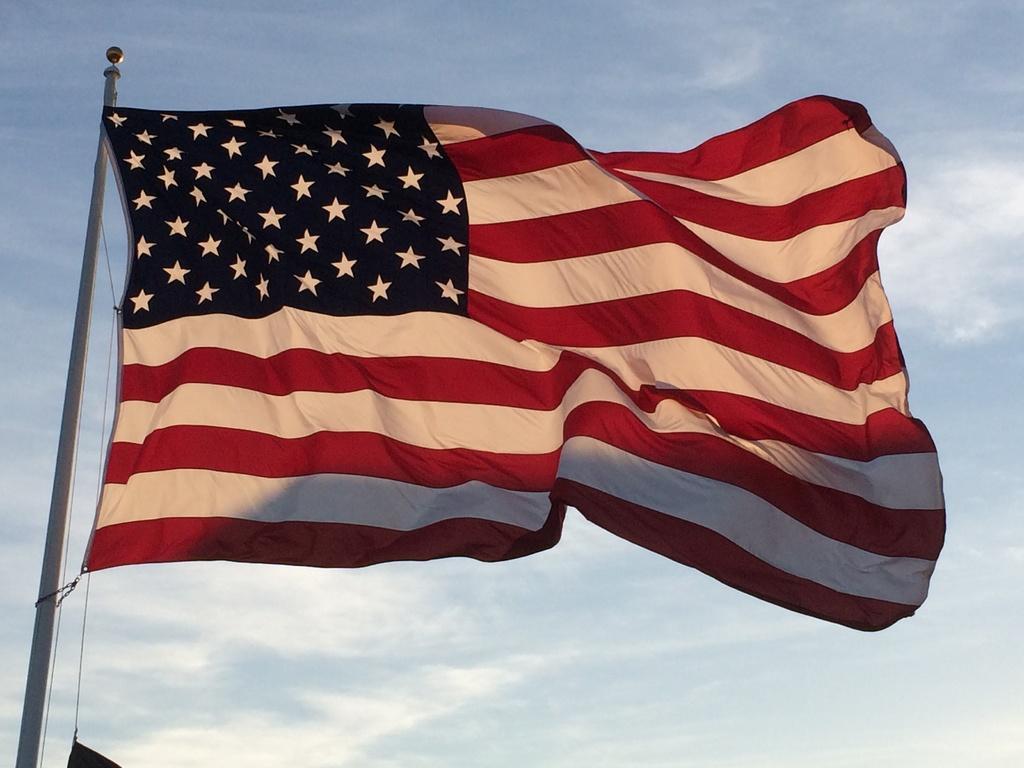Can you describe this image briefly? In this picture we can see the American flag here, on the left side there is a flag post, in the background there is the sky. 